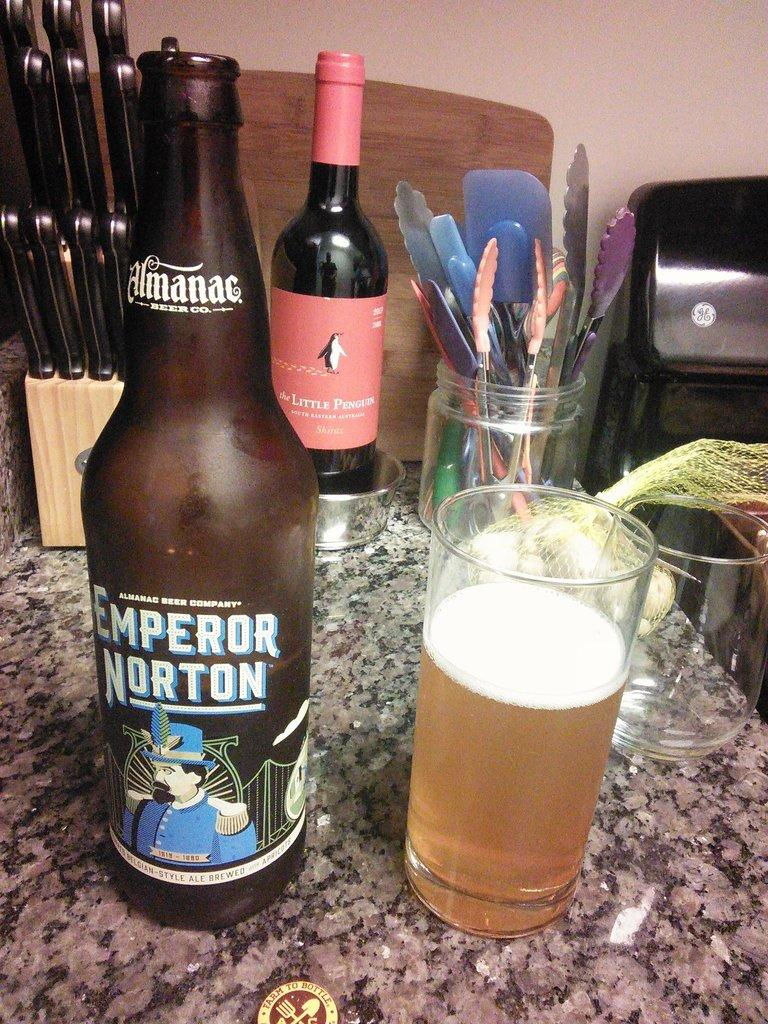<image>
Write a terse but informative summary of the picture. A glass of beer is next to a beer bottle that says Emperor Norton on a granite counter. 